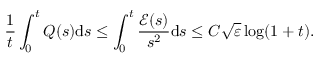<formula> <loc_0><loc_0><loc_500><loc_500>\frac { 1 } { t } \int _ { 0 } ^ { t } Q ( s ) d s \leq \int _ { 0 } ^ { t } \frac { \mathcal { E } ( s ) } { s ^ { 2 } } d s \leq C \sqrt { \varepsilon } \log ( 1 + t ) .</formula> 